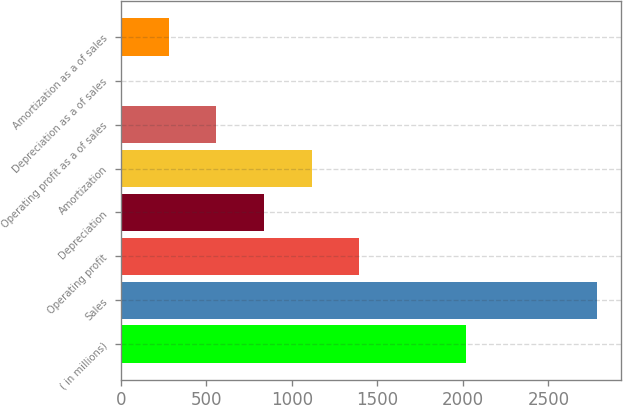<chart> <loc_0><loc_0><loc_500><loc_500><bar_chart><fcel>( in millions)<fcel>Sales<fcel>Operating profit<fcel>Depreciation<fcel>Amortization<fcel>Operating profit as a of sales<fcel>Depreciation as a of sales<fcel>Amortization as a of sales<nl><fcel>2016<fcel>2785.4<fcel>1393.5<fcel>836.74<fcel>1115.12<fcel>558.36<fcel>1.6<fcel>279.98<nl></chart> 